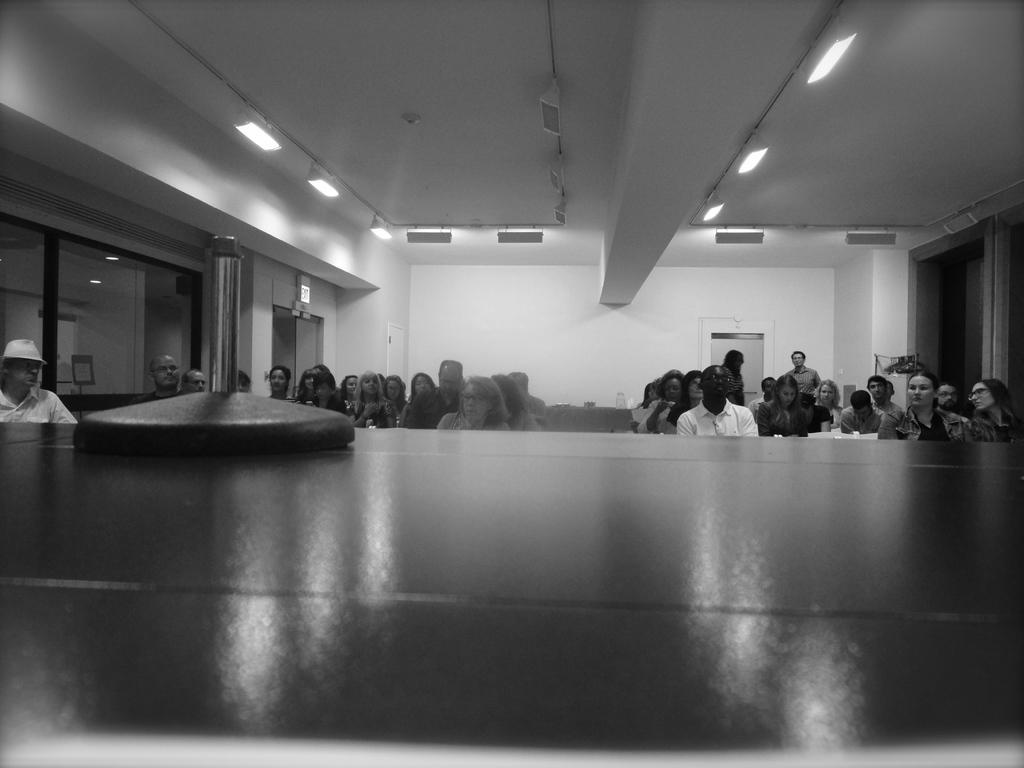Please provide a concise description of this image. At the bottom of the image there is a platform with an object on it. Behind the platform there are few people sitting. In the background there is a wall with doors and glass walls. At the top of the image there is a ceiling with lights. 